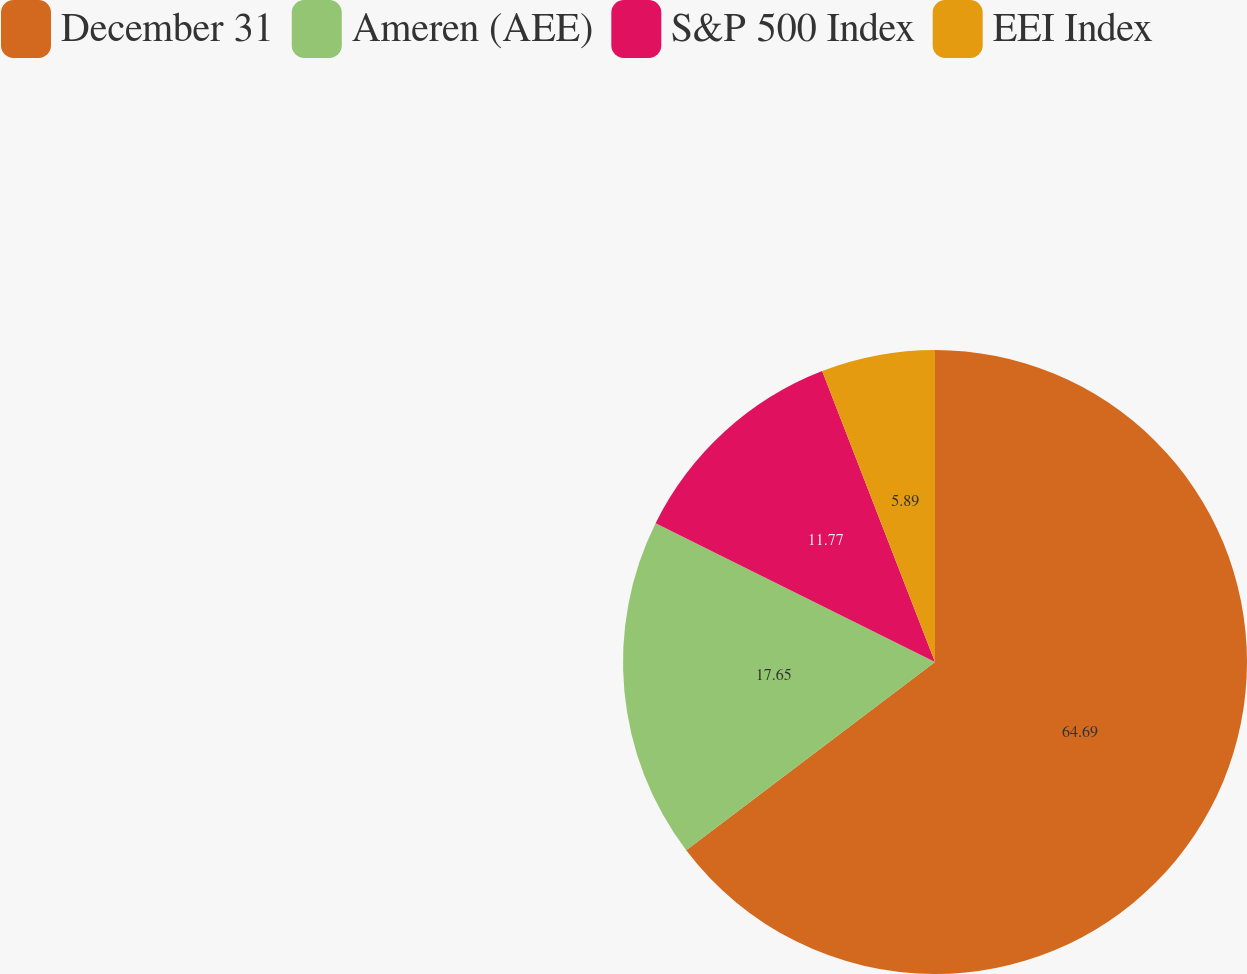<chart> <loc_0><loc_0><loc_500><loc_500><pie_chart><fcel>December 31<fcel>Ameren (AEE)<fcel>S&P 500 Index<fcel>EEI Index<nl><fcel>64.69%<fcel>17.65%<fcel>11.77%<fcel>5.89%<nl></chart> 